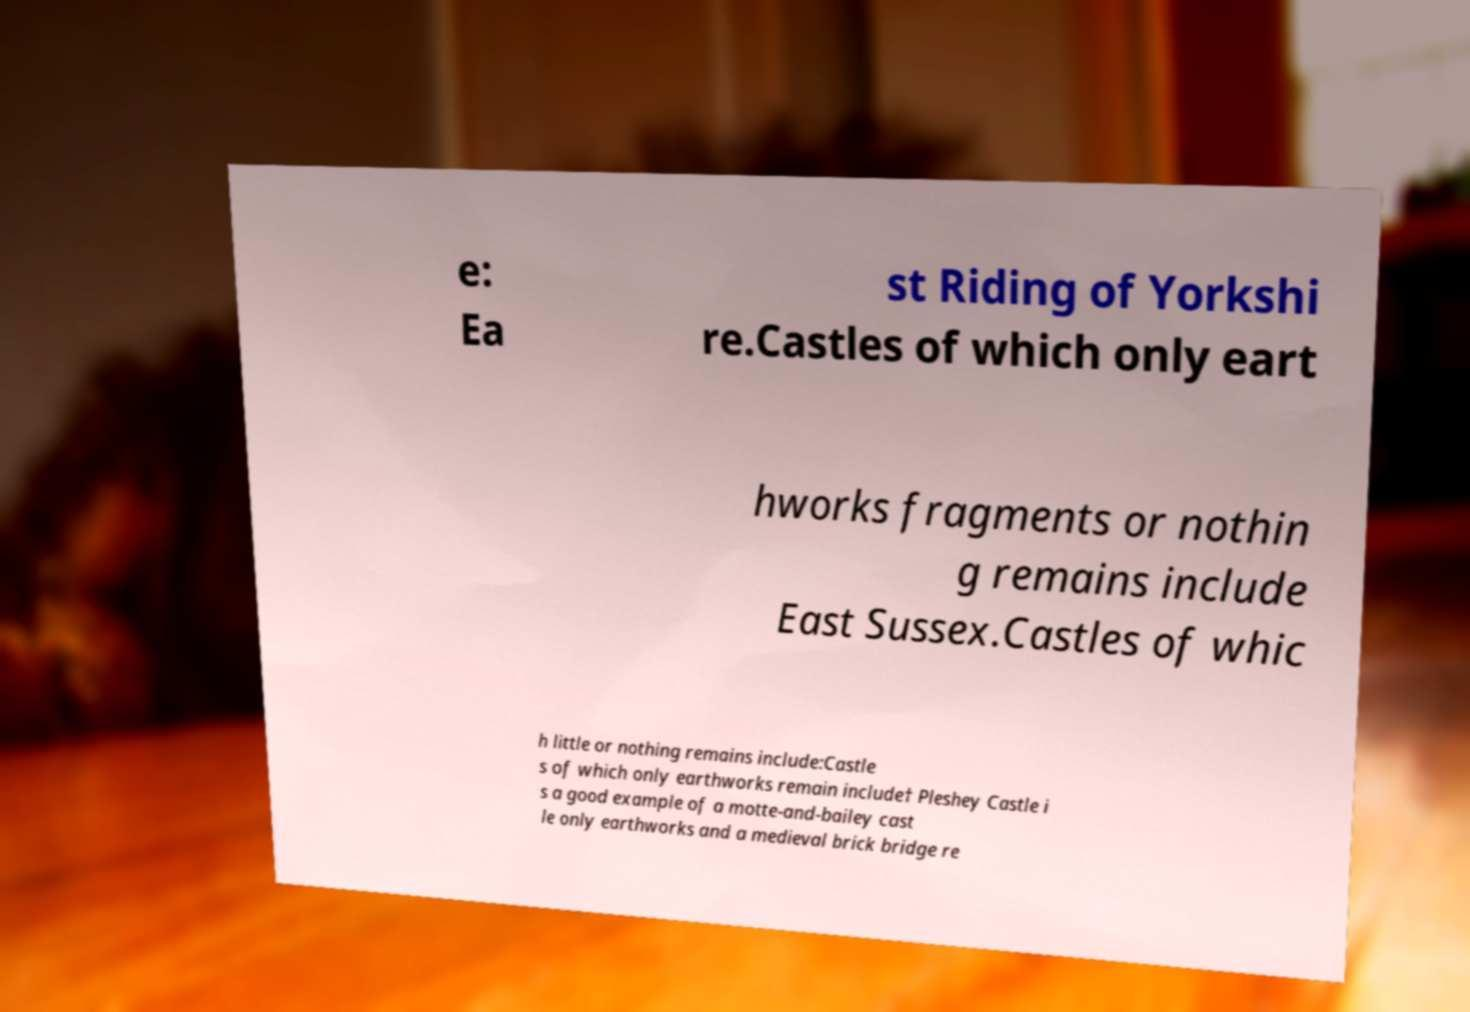Can you accurately transcribe the text from the provided image for me? e: Ea st Riding of Yorkshi re.Castles of which only eart hworks fragments or nothin g remains include East Sussex.Castles of whic h little or nothing remains include:Castle s of which only earthworks remain include† Pleshey Castle i s a good example of a motte-and-bailey cast le only earthworks and a medieval brick bridge re 